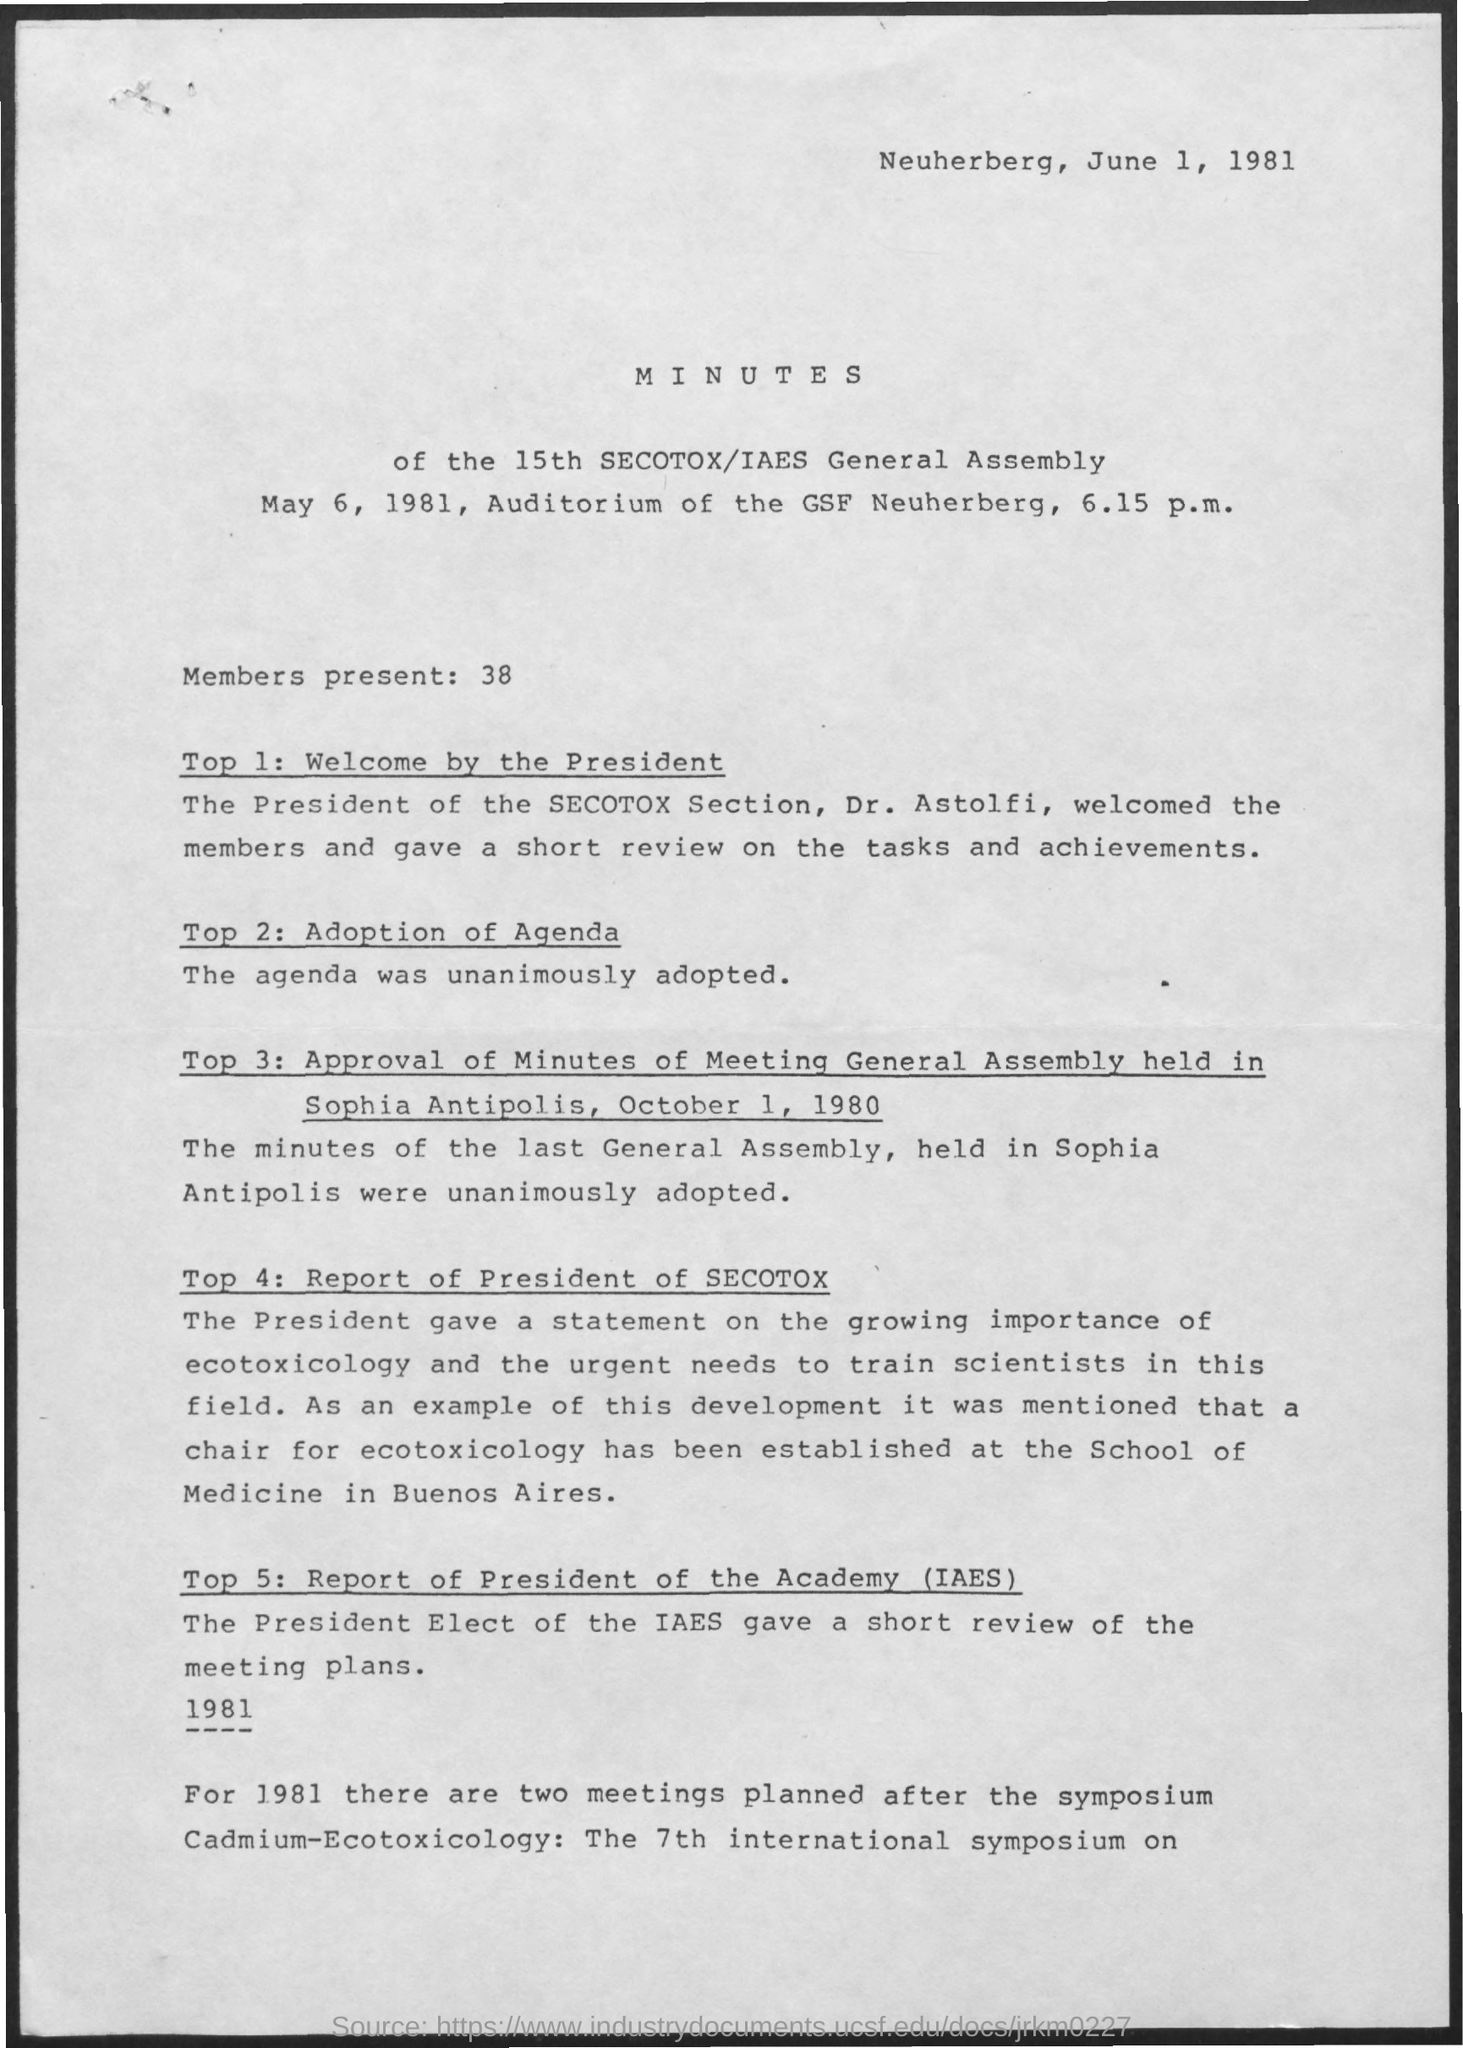What is the document about?
Your response must be concise. Minutes of the 15th SECOTOX/IAES General Assembly. When is the document dated?
Ensure brevity in your answer.  June 1, 1981. On which date was the general assembly held?
Make the answer very short. May 6, 1981. How many members were present?
Your answer should be very brief. 38. Who is the President of the SECOTOX Section?
Your response must be concise. Dr. Astolfi. 